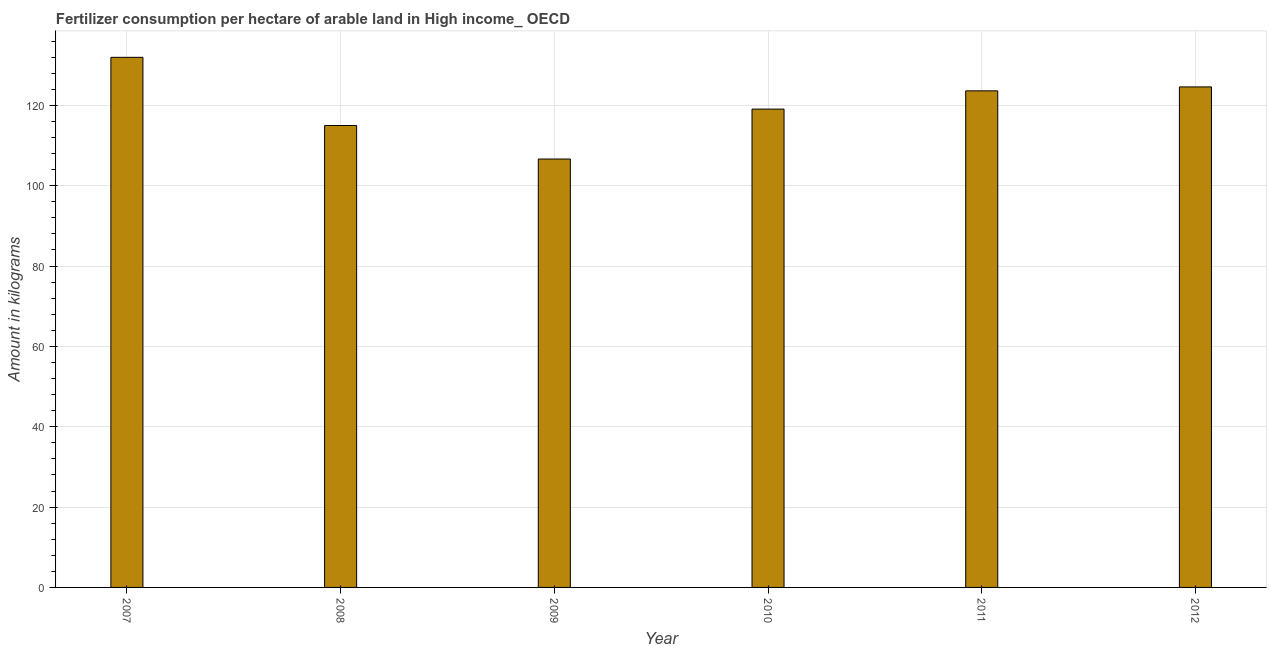Does the graph contain any zero values?
Your response must be concise. No. Does the graph contain grids?
Your answer should be compact. Yes. What is the title of the graph?
Your answer should be very brief. Fertilizer consumption per hectare of arable land in High income_ OECD . What is the label or title of the Y-axis?
Ensure brevity in your answer.  Amount in kilograms. What is the amount of fertilizer consumption in 2012?
Provide a short and direct response. 124.58. Across all years, what is the maximum amount of fertilizer consumption?
Ensure brevity in your answer.  131.94. Across all years, what is the minimum amount of fertilizer consumption?
Provide a succinct answer. 106.63. In which year was the amount of fertilizer consumption maximum?
Your answer should be compact. 2007. What is the sum of the amount of fertilizer consumption?
Keep it short and to the point. 720.77. What is the difference between the amount of fertilizer consumption in 2010 and 2012?
Provide a short and direct response. -5.52. What is the average amount of fertilizer consumption per year?
Ensure brevity in your answer.  120.13. What is the median amount of fertilizer consumption?
Provide a succinct answer. 121.33. In how many years, is the amount of fertilizer consumption greater than 68 kg?
Keep it short and to the point. 6. Do a majority of the years between 2009 and 2011 (inclusive) have amount of fertilizer consumption greater than 48 kg?
Provide a succinct answer. Yes. What is the ratio of the amount of fertilizer consumption in 2007 to that in 2009?
Provide a succinct answer. 1.24. What is the difference between the highest and the second highest amount of fertilizer consumption?
Your answer should be compact. 7.36. Is the sum of the amount of fertilizer consumption in 2009 and 2012 greater than the maximum amount of fertilizer consumption across all years?
Provide a succinct answer. Yes. What is the difference between the highest and the lowest amount of fertilizer consumption?
Make the answer very short. 25.31. How many bars are there?
Offer a terse response. 6. Are all the bars in the graph horizontal?
Your response must be concise. No. What is the Amount in kilograms of 2007?
Make the answer very short. 131.94. What is the Amount in kilograms of 2008?
Provide a succinct answer. 114.97. What is the Amount in kilograms in 2009?
Offer a terse response. 106.63. What is the Amount in kilograms of 2010?
Keep it short and to the point. 119.05. What is the Amount in kilograms of 2011?
Provide a short and direct response. 123.6. What is the Amount in kilograms of 2012?
Ensure brevity in your answer.  124.58. What is the difference between the Amount in kilograms in 2007 and 2008?
Make the answer very short. 16.97. What is the difference between the Amount in kilograms in 2007 and 2009?
Ensure brevity in your answer.  25.31. What is the difference between the Amount in kilograms in 2007 and 2010?
Keep it short and to the point. 12.89. What is the difference between the Amount in kilograms in 2007 and 2011?
Ensure brevity in your answer.  8.34. What is the difference between the Amount in kilograms in 2007 and 2012?
Ensure brevity in your answer.  7.36. What is the difference between the Amount in kilograms in 2008 and 2009?
Your answer should be very brief. 8.34. What is the difference between the Amount in kilograms in 2008 and 2010?
Offer a terse response. -4.08. What is the difference between the Amount in kilograms in 2008 and 2011?
Make the answer very short. -8.63. What is the difference between the Amount in kilograms in 2008 and 2012?
Your answer should be very brief. -9.61. What is the difference between the Amount in kilograms in 2009 and 2010?
Provide a succinct answer. -12.43. What is the difference between the Amount in kilograms in 2009 and 2011?
Give a very brief answer. -16.97. What is the difference between the Amount in kilograms in 2009 and 2012?
Your answer should be compact. -17.95. What is the difference between the Amount in kilograms in 2010 and 2011?
Your answer should be very brief. -4.54. What is the difference between the Amount in kilograms in 2010 and 2012?
Provide a short and direct response. -5.52. What is the difference between the Amount in kilograms in 2011 and 2012?
Your response must be concise. -0.98. What is the ratio of the Amount in kilograms in 2007 to that in 2008?
Your answer should be very brief. 1.15. What is the ratio of the Amount in kilograms in 2007 to that in 2009?
Make the answer very short. 1.24. What is the ratio of the Amount in kilograms in 2007 to that in 2010?
Offer a terse response. 1.11. What is the ratio of the Amount in kilograms in 2007 to that in 2011?
Your answer should be compact. 1.07. What is the ratio of the Amount in kilograms in 2007 to that in 2012?
Your answer should be very brief. 1.06. What is the ratio of the Amount in kilograms in 2008 to that in 2009?
Ensure brevity in your answer.  1.08. What is the ratio of the Amount in kilograms in 2008 to that in 2012?
Your answer should be compact. 0.92. What is the ratio of the Amount in kilograms in 2009 to that in 2010?
Keep it short and to the point. 0.9. What is the ratio of the Amount in kilograms in 2009 to that in 2011?
Offer a very short reply. 0.86. What is the ratio of the Amount in kilograms in 2009 to that in 2012?
Your response must be concise. 0.86. What is the ratio of the Amount in kilograms in 2010 to that in 2012?
Ensure brevity in your answer.  0.96. What is the ratio of the Amount in kilograms in 2011 to that in 2012?
Your answer should be very brief. 0.99. 